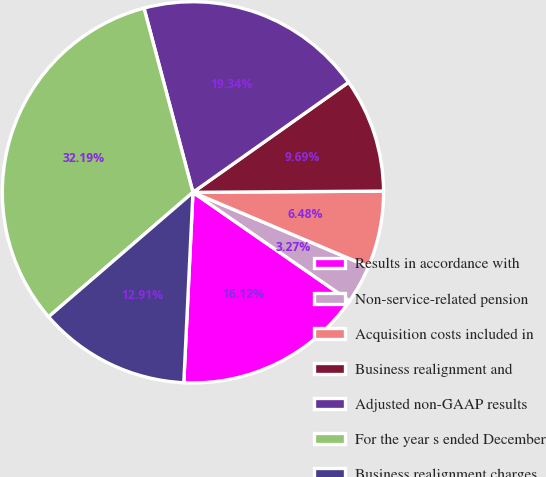<chart> <loc_0><loc_0><loc_500><loc_500><pie_chart><fcel>Results in accordance with<fcel>Non-service-related pension<fcel>Acquisition costs included in<fcel>Business realignment and<fcel>Adjusted non-GAAP results<fcel>For the year s ended December<fcel>Business realignment charges<nl><fcel>16.12%<fcel>3.27%<fcel>6.48%<fcel>9.69%<fcel>19.34%<fcel>32.19%<fcel>12.91%<nl></chart> 